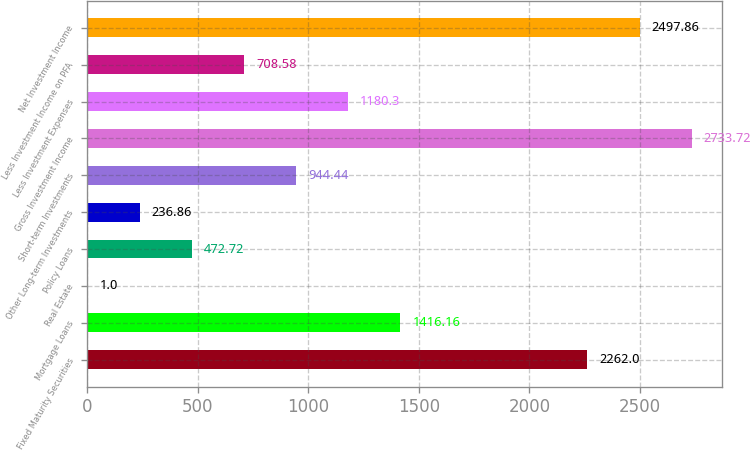<chart> <loc_0><loc_0><loc_500><loc_500><bar_chart><fcel>Fixed Maturity Securities<fcel>Mortgage Loans<fcel>Real Estate<fcel>Policy Loans<fcel>Other Long-term Investments<fcel>Short-term Investments<fcel>Gross Investment Income<fcel>Less Investment Expenses<fcel>Less Investment Income on PFA<fcel>Net Investment Income<nl><fcel>2262<fcel>1416.16<fcel>1<fcel>472.72<fcel>236.86<fcel>944.44<fcel>2733.72<fcel>1180.3<fcel>708.58<fcel>2497.86<nl></chart> 